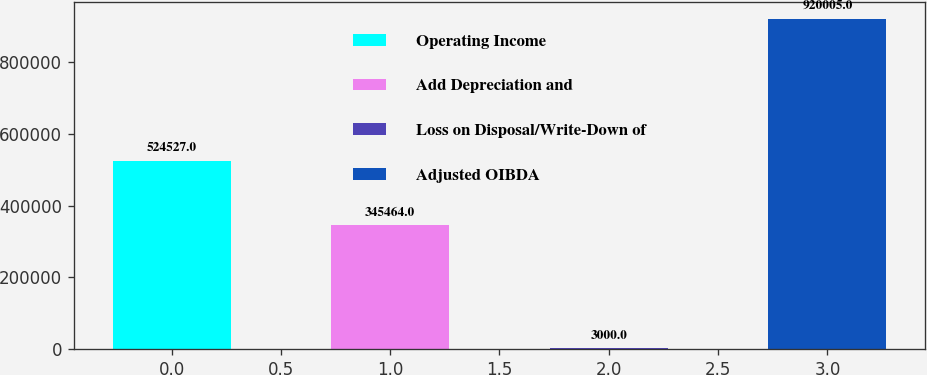Convert chart. <chart><loc_0><loc_0><loc_500><loc_500><bar_chart><fcel>Operating Income<fcel>Add Depreciation and<fcel>Loss on Disposal/Write-Down of<fcel>Adjusted OIBDA<nl><fcel>524527<fcel>345464<fcel>3000<fcel>920005<nl></chart> 